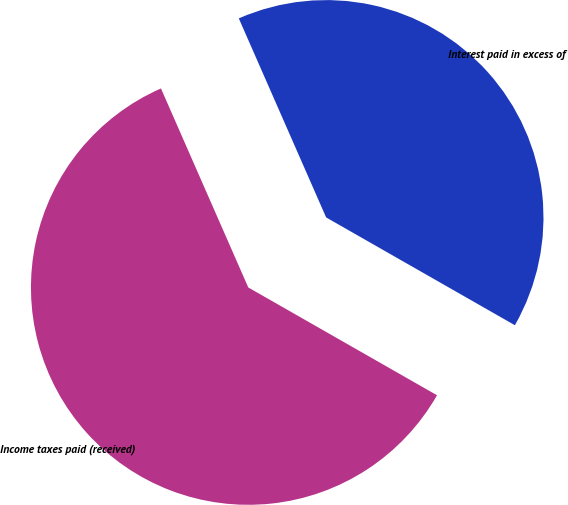Convert chart. <chart><loc_0><loc_0><loc_500><loc_500><pie_chart><fcel>Interest paid in excess of<fcel>Income taxes paid (received)<nl><fcel>39.84%<fcel>60.16%<nl></chart> 